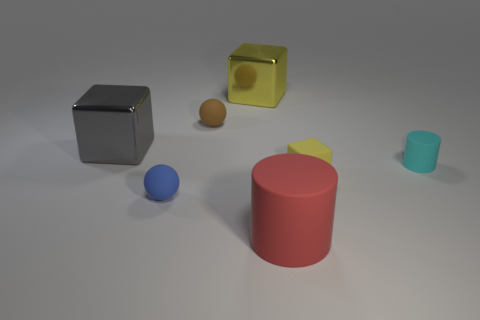Add 2 small gray metal spheres. How many objects exist? 9 Subtract all cylinders. How many objects are left? 5 Add 5 big red spheres. How many big red spheres exist? 5 Subtract 0 green cylinders. How many objects are left? 7 Subtract all tiny blue rubber objects. Subtract all gray metallic things. How many objects are left? 5 Add 4 gray blocks. How many gray blocks are left? 5 